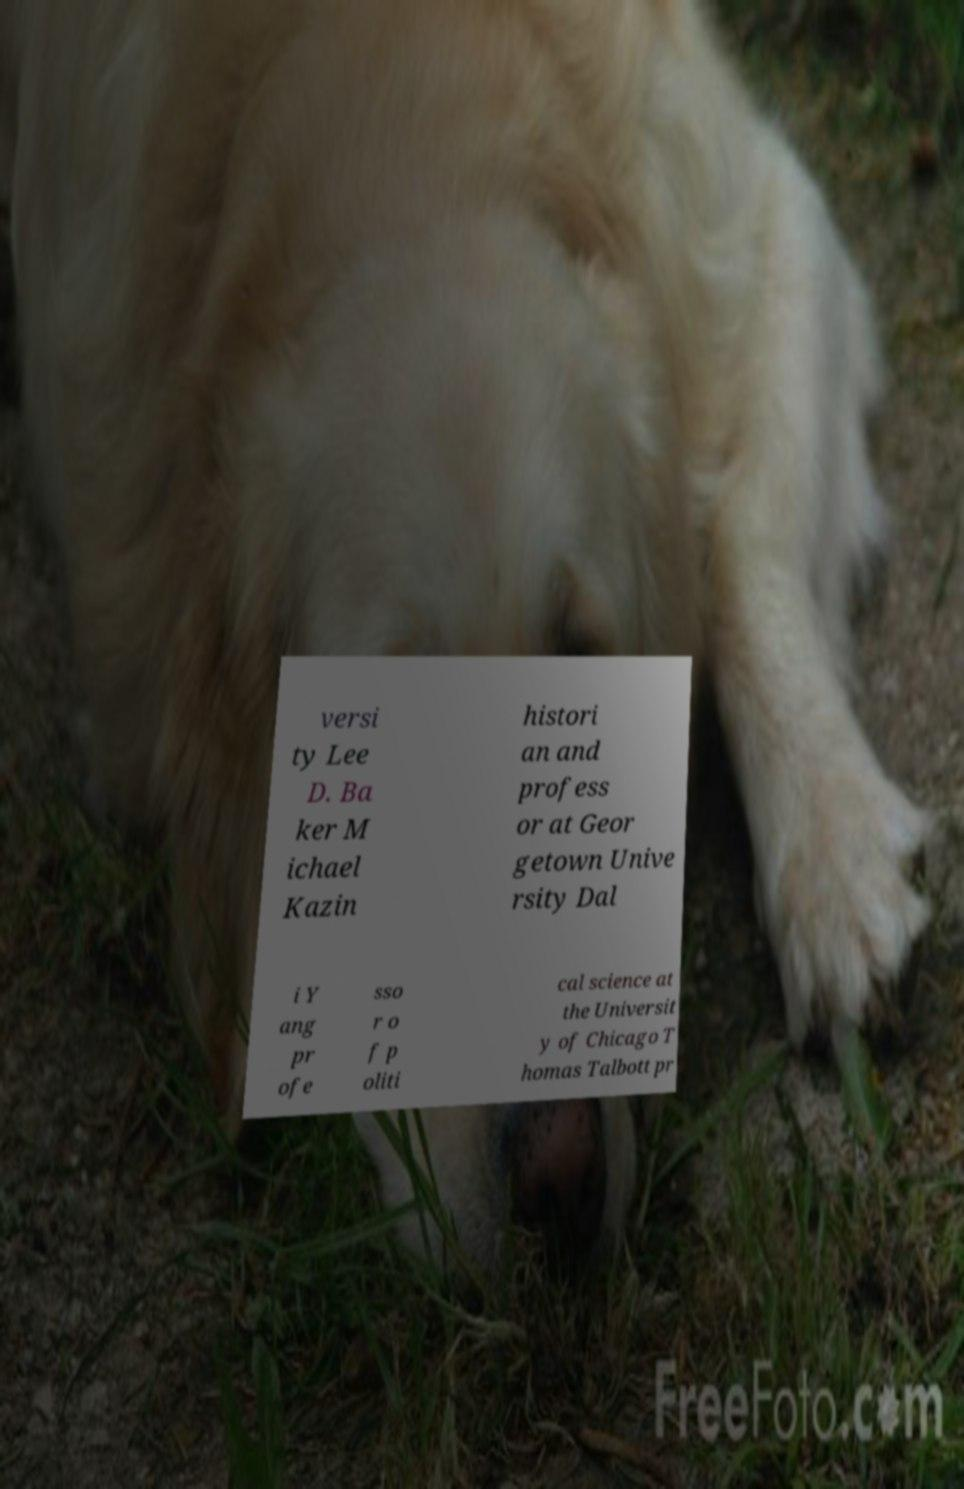Please identify and transcribe the text found in this image. versi ty Lee D. Ba ker M ichael Kazin histori an and profess or at Geor getown Unive rsity Dal i Y ang pr ofe sso r o f p oliti cal science at the Universit y of Chicago T homas Talbott pr 